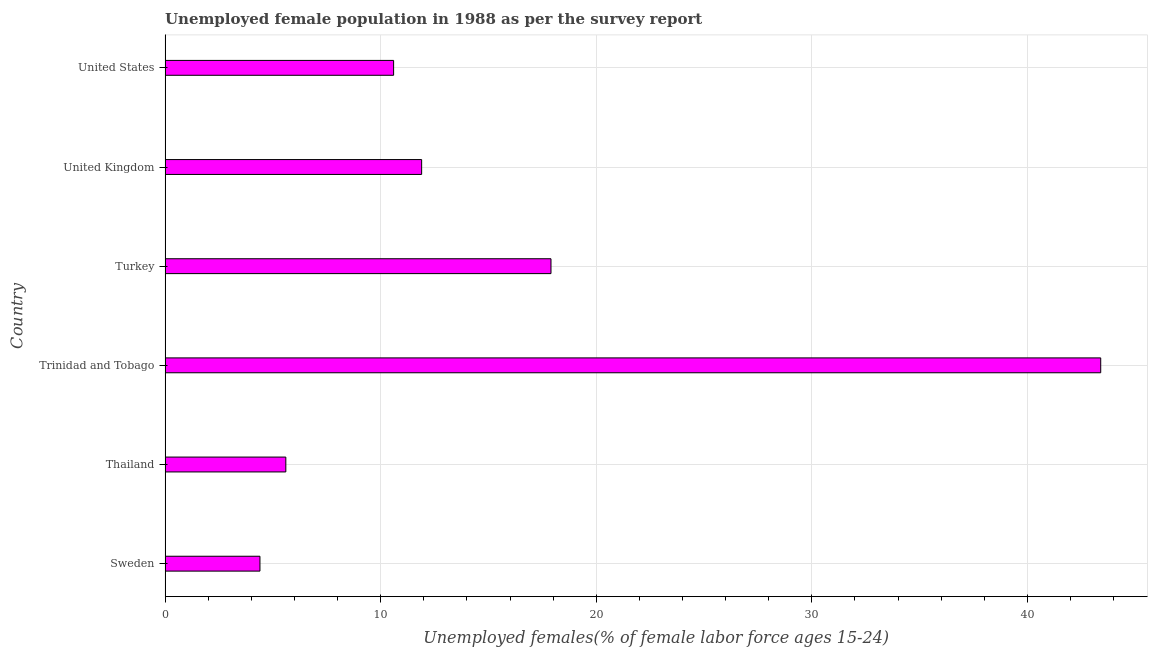What is the title of the graph?
Provide a succinct answer. Unemployed female population in 1988 as per the survey report. What is the label or title of the X-axis?
Offer a terse response. Unemployed females(% of female labor force ages 15-24). What is the unemployed female youth in United Kingdom?
Your answer should be compact. 11.9. Across all countries, what is the maximum unemployed female youth?
Offer a terse response. 43.4. Across all countries, what is the minimum unemployed female youth?
Provide a short and direct response. 4.4. In which country was the unemployed female youth maximum?
Ensure brevity in your answer.  Trinidad and Tobago. What is the sum of the unemployed female youth?
Your answer should be very brief. 93.8. What is the difference between the unemployed female youth in Sweden and Trinidad and Tobago?
Your answer should be compact. -39. What is the average unemployed female youth per country?
Provide a succinct answer. 15.63. What is the median unemployed female youth?
Provide a succinct answer. 11.25. What is the ratio of the unemployed female youth in Trinidad and Tobago to that in United States?
Your response must be concise. 4.09. Is the unemployed female youth in Sweden less than that in Trinidad and Tobago?
Your answer should be very brief. Yes. Is the difference between the unemployed female youth in Turkey and United States greater than the difference between any two countries?
Offer a terse response. No. What is the difference between the highest and the second highest unemployed female youth?
Ensure brevity in your answer.  25.5. How many countries are there in the graph?
Make the answer very short. 6. What is the difference between two consecutive major ticks on the X-axis?
Offer a very short reply. 10. What is the Unemployed females(% of female labor force ages 15-24) of Sweden?
Offer a terse response. 4.4. What is the Unemployed females(% of female labor force ages 15-24) in Thailand?
Your answer should be very brief. 5.6. What is the Unemployed females(% of female labor force ages 15-24) in Trinidad and Tobago?
Provide a short and direct response. 43.4. What is the Unemployed females(% of female labor force ages 15-24) of Turkey?
Give a very brief answer. 17.9. What is the Unemployed females(% of female labor force ages 15-24) of United Kingdom?
Offer a very short reply. 11.9. What is the Unemployed females(% of female labor force ages 15-24) in United States?
Offer a terse response. 10.6. What is the difference between the Unemployed females(% of female labor force ages 15-24) in Sweden and Trinidad and Tobago?
Offer a very short reply. -39. What is the difference between the Unemployed females(% of female labor force ages 15-24) in Sweden and United States?
Your answer should be very brief. -6.2. What is the difference between the Unemployed females(% of female labor force ages 15-24) in Thailand and Trinidad and Tobago?
Offer a terse response. -37.8. What is the difference between the Unemployed females(% of female labor force ages 15-24) in Trinidad and Tobago and Turkey?
Make the answer very short. 25.5. What is the difference between the Unemployed females(% of female labor force ages 15-24) in Trinidad and Tobago and United Kingdom?
Your response must be concise. 31.5. What is the difference between the Unemployed females(% of female labor force ages 15-24) in Trinidad and Tobago and United States?
Make the answer very short. 32.8. What is the difference between the Unemployed females(% of female labor force ages 15-24) in Turkey and United Kingdom?
Your answer should be compact. 6. What is the ratio of the Unemployed females(% of female labor force ages 15-24) in Sweden to that in Thailand?
Give a very brief answer. 0.79. What is the ratio of the Unemployed females(% of female labor force ages 15-24) in Sweden to that in Trinidad and Tobago?
Your answer should be very brief. 0.1. What is the ratio of the Unemployed females(% of female labor force ages 15-24) in Sweden to that in Turkey?
Your answer should be very brief. 0.25. What is the ratio of the Unemployed females(% of female labor force ages 15-24) in Sweden to that in United Kingdom?
Your answer should be compact. 0.37. What is the ratio of the Unemployed females(% of female labor force ages 15-24) in Sweden to that in United States?
Ensure brevity in your answer.  0.41. What is the ratio of the Unemployed females(% of female labor force ages 15-24) in Thailand to that in Trinidad and Tobago?
Provide a short and direct response. 0.13. What is the ratio of the Unemployed females(% of female labor force ages 15-24) in Thailand to that in Turkey?
Your answer should be compact. 0.31. What is the ratio of the Unemployed females(% of female labor force ages 15-24) in Thailand to that in United Kingdom?
Ensure brevity in your answer.  0.47. What is the ratio of the Unemployed females(% of female labor force ages 15-24) in Thailand to that in United States?
Your response must be concise. 0.53. What is the ratio of the Unemployed females(% of female labor force ages 15-24) in Trinidad and Tobago to that in Turkey?
Your answer should be very brief. 2.42. What is the ratio of the Unemployed females(% of female labor force ages 15-24) in Trinidad and Tobago to that in United Kingdom?
Make the answer very short. 3.65. What is the ratio of the Unemployed females(% of female labor force ages 15-24) in Trinidad and Tobago to that in United States?
Offer a terse response. 4.09. What is the ratio of the Unemployed females(% of female labor force ages 15-24) in Turkey to that in United Kingdom?
Provide a short and direct response. 1.5. What is the ratio of the Unemployed females(% of female labor force ages 15-24) in Turkey to that in United States?
Offer a terse response. 1.69. What is the ratio of the Unemployed females(% of female labor force ages 15-24) in United Kingdom to that in United States?
Provide a succinct answer. 1.12. 